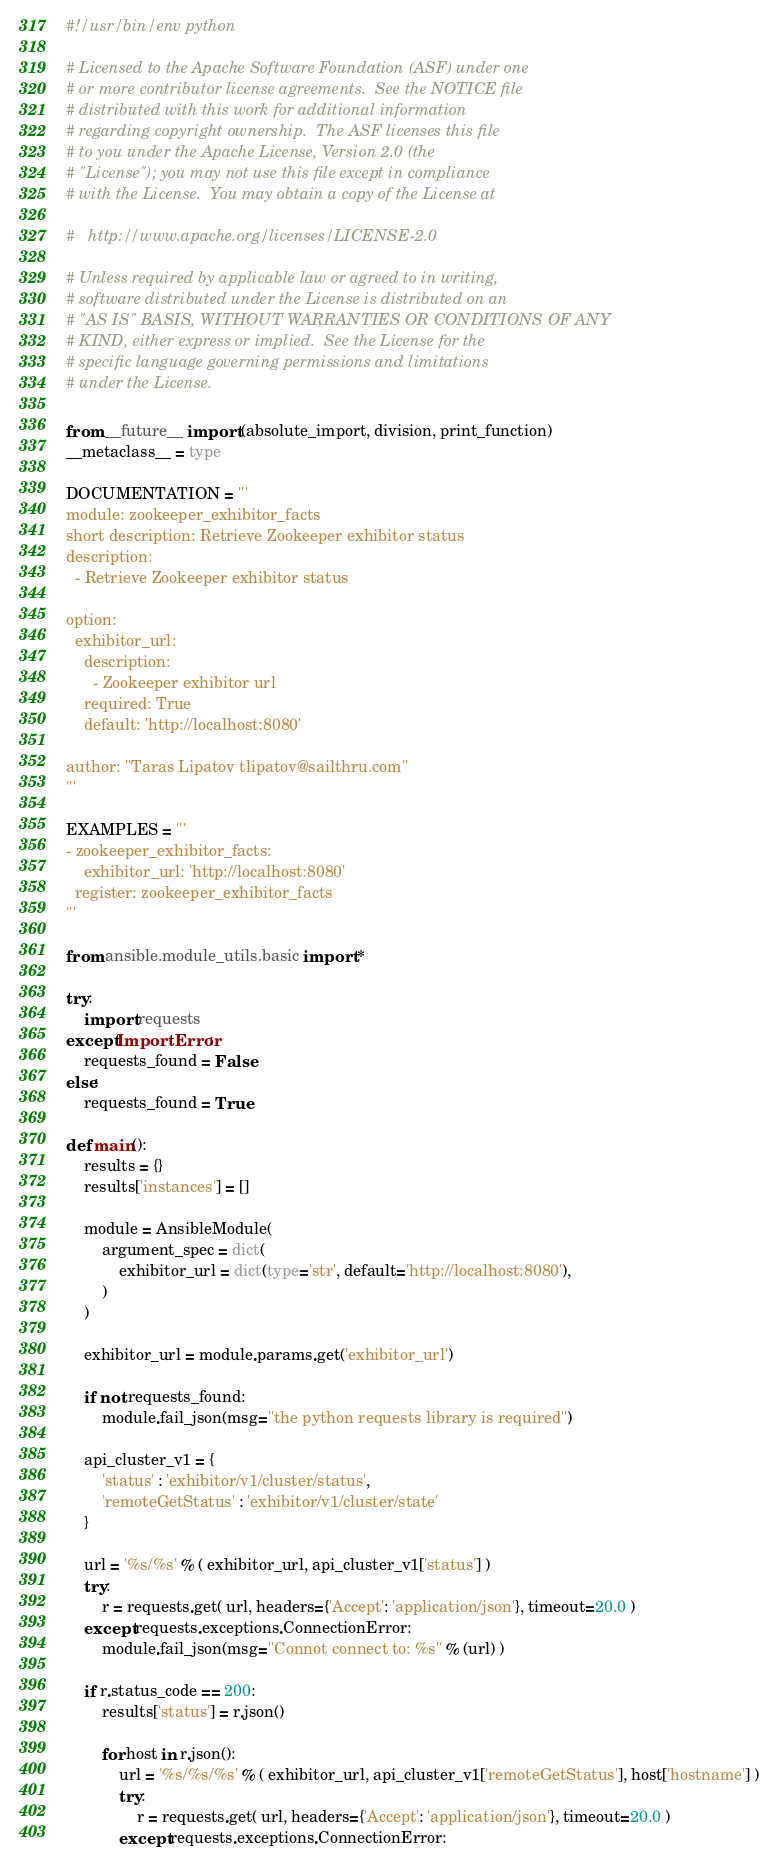<code> <loc_0><loc_0><loc_500><loc_500><_Python_>#!/usr/bin/env python

# Licensed to the Apache Software Foundation (ASF) under one
# or more contributor license agreements.  See the NOTICE file
# distributed with this work for additional information
# regarding copyright ownership.  The ASF licenses this file
# to you under the Apache License, Version 2.0 (the
# "License"); you may not use this file except in compliance
# with the License.  You may obtain a copy of the License at

#   http://www.apache.org/licenses/LICENSE-2.0

# Unless required by applicable law or agreed to in writing,
# software distributed under the License is distributed on an
# "AS IS" BASIS, WITHOUT WARRANTIES OR CONDITIONS OF ANY
# KIND, either express or implied.  See the License for the
# specific language governing permissions and limitations
# under the License.

from __future__ import (absolute_import, division, print_function)
__metaclass__ = type

DOCUMENTATION = '''
module: zookeeper_exhibitor_facts
short description: Retrieve Zookeeper exhibitor status
description:
  - Retrieve Zookeeper exhibitor status

option:
  exhibitor_url:
    description:
      - Zookeeper exhibitor url
    required: True 
    default: 'http://localhost:8080'

author: "Taras Lipatov tlipatov@sailthru.com"
'''

EXAMPLES = '''
- zookeeper_exhibitor_facts:
    exhibitor_url: 'http://localhost:8080'
  register: zookeeper_exhibitor_facts
'''

from ansible.module_utils.basic import *

try:
    import requests
except ImportError:
    requests_found = False
else:
    requests_found = True

def main():
    results = {}
    results['instances'] = []

    module = AnsibleModule(
        argument_spec = dict(
            exhibitor_url = dict(type='str', default='http://localhost:8080'),
        )
    )

    exhibitor_url = module.params.get('exhibitor_url')

    if not requests_found:
        module.fail_json(msg="the python requests library is required")

    api_cluster_v1 = {
        'status' : 'exhibitor/v1/cluster/status',
        'remoteGetStatus' : 'exhibitor/v1/cluster/state'
    }

    url = '%s/%s' % ( exhibitor_url, api_cluster_v1['status'] )
    try:
        r = requests.get( url, headers={'Accept': 'application/json'}, timeout=20.0 )
    except requests.exceptions.ConnectionError:
        module.fail_json(msg="Connot connect to: %s" % (url) )

    if r.status_code == 200:
        results['status'] = r.json()

        for host in r.json():
            url = '%s/%s/%s' % ( exhibitor_url, api_cluster_v1['remoteGetStatus'], host['hostname'] )
            try:
                r = requests.get( url, headers={'Accept': 'application/json'}, timeout=20.0 )
            except requests.exceptions.ConnectionError:</code> 